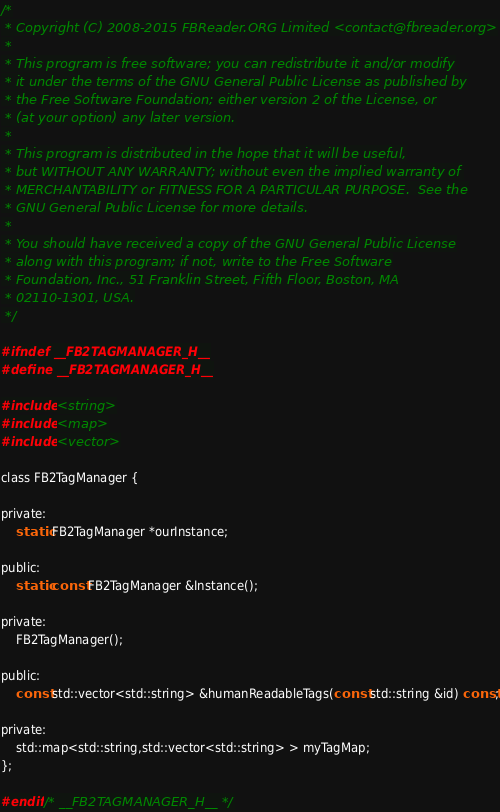<code> <loc_0><loc_0><loc_500><loc_500><_C_>/*
 * Copyright (C) 2008-2015 FBReader.ORG Limited <contact@fbreader.org>
 *
 * This program is free software; you can redistribute it and/or modify
 * it under the terms of the GNU General Public License as published by
 * the Free Software Foundation; either version 2 of the License, or
 * (at your option) any later version.
 *
 * This program is distributed in the hope that it will be useful,
 * but WITHOUT ANY WARRANTY; without even the implied warranty of
 * MERCHANTABILITY or FITNESS FOR A PARTICULAR PURPOSE.  See the
 * GNU General Public License for more details.
 *
 * You should have received a copy of the GNU General Public License
 * along with this program; if not, write to the Free Software
 * Foundation, Inc., 51 Franklin Street, Fifth Floor, Boston, MA
 * 02110-1301, USA.
 */

#ifndef __FB2TAGMANAGER_H__
#define __FB2TAGMANAGER_H__

#include <string>
#include <map>
#include <vector>

class FB2TagManager {

private:
	static FB2TagManager *ourInstance;

public:
	static const FB2TagManager &Instance();

private:
	FB2TagManager();

public:
	const std::vector<std::string> &humanReadableTags(const std::string &id) const;

private:
	std::map<std::string,std::vector<std::string> > myTagMap;
};

#endif /* __FB2TAGMANAGER_H__ */
</code> 